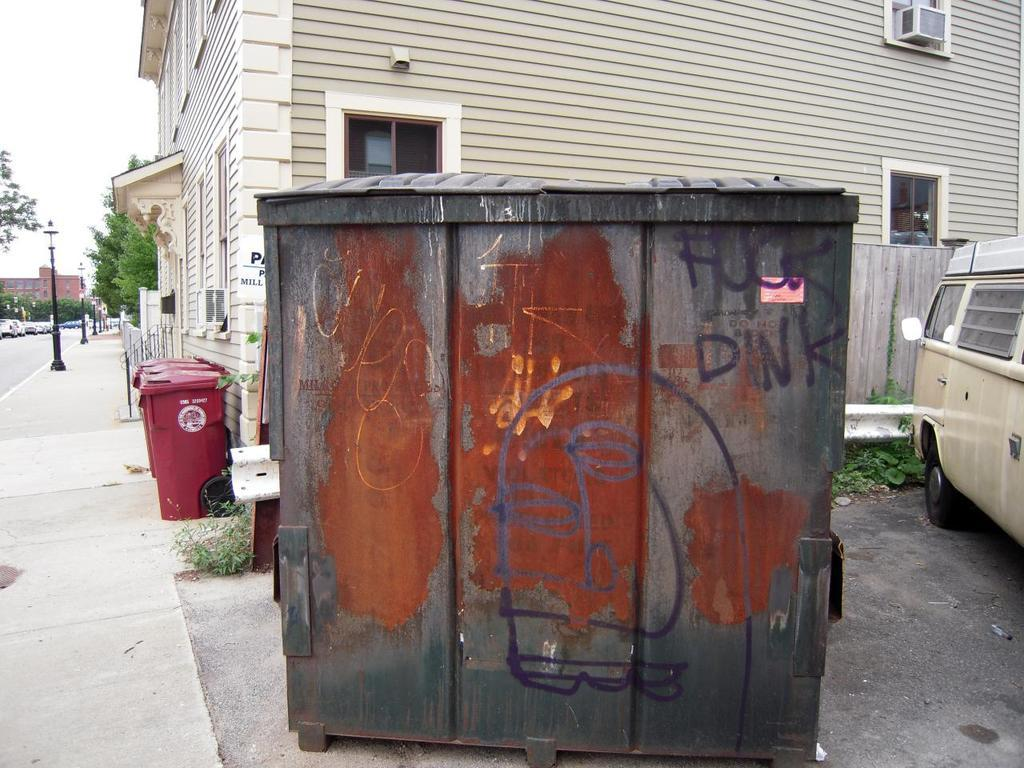What is the wooden object with text in the image? The wooden object with text in the image is not specified, but it has text on it. What type of vehicle can be seen in the image? A car is visible in the image. What type of lighting is present in the image? Street lights are present in the image. What type of waste disposal container is visible on the path in the image? A dust bin is visible on the path in the image. What type of vegetation can be seen in the background of the image? There are trees in the background of the image. What type of structures can be seen in the background of the image? There are buildings in the background of the image. What type of birthday celebration is taking place in the image? There is no indication of a birthday celebration in the image. What type of belief is represented by the text on the wooden object in the image? The text on the wooden object is not specified, so it is impossible to determine what belief it might represent. 